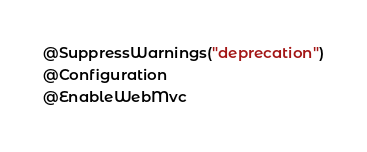Convert code to text. <code><loc_0><loc_0><loc_500><loc_500><_Java_>@SuppressWarnings("deprecation")
@Configuration
@EnableWebMvc</code> 